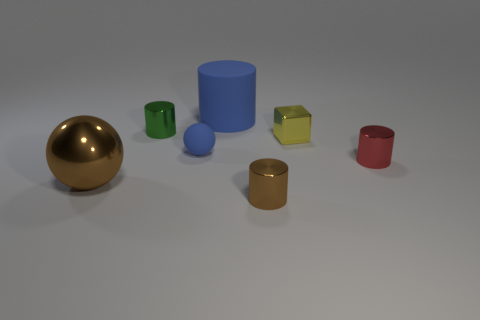There is a big cylinder that is the same color as the tiny matte sphere; what is its material?
Give a very brief answer. Rubber. How big is the shiny cylinder left of the blue object in front of the metal cylinder that is on the left side of the small blue ball?
Your answer should be compact. Small. Is the shape of the big blue rubber object the same as the matte thing that is in front of the small green metallic cylinder?
Ensure brevity in your answer.  No. Are there any other large metallic spheres of the same color as the large sphere?
Your response must be concise. No. How many cylinders are big brown things or green metal things?
Your answer should be very brief. 1. Are there any red metal objects of the same shape as the small green metallic thing?
Make the answer very short. Yes. What number of other things are the same color as the matte cylinder?
Provide a succinct answer. 1. Is the number of tiny yellow shiny objects that are behind the matte sphere less than the number of large rubber cylinders?
Offer a very short reply. No. What number of small cylinders are there?
Provide a succinct answer. 3. How many small green cylinders have the same material as the small yellow object?
Make the answer very short. 1. 